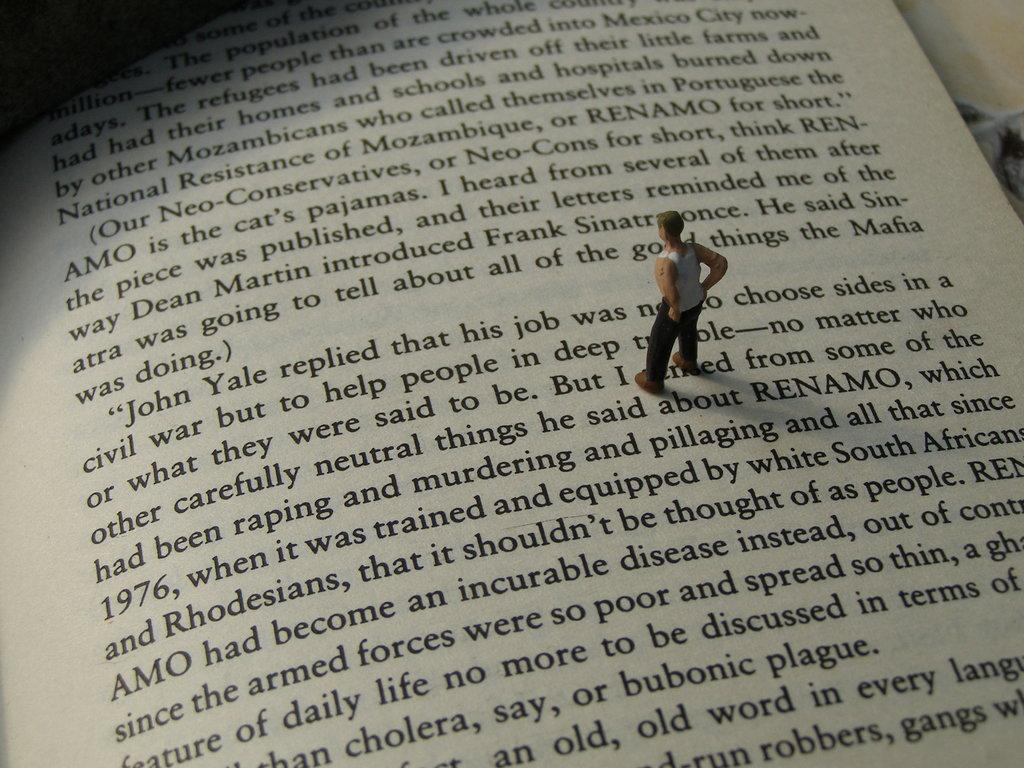Provide a one-sentence caption for the provided image. A book with a little toy man reading about John Yale. 